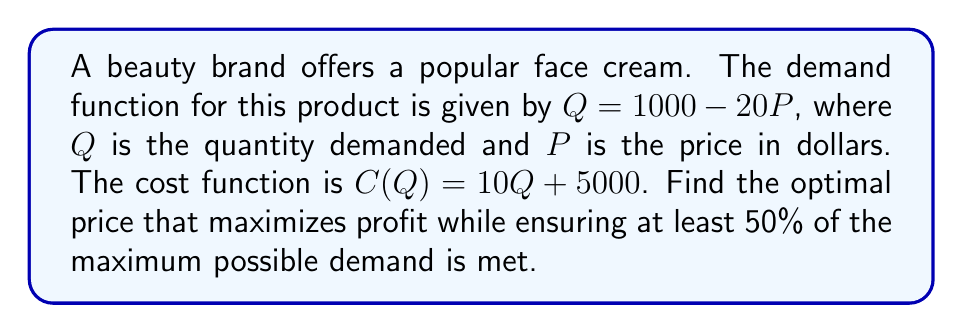What is the answer to this math problem? To solve this optimization problem, we'll follow these steps:

1) First, let's find the revenue function $R(P)$:
   $R(P) = P \cdot Q = P(1000 - 20P) = 1000P - 20P^2$

2) The cost function in terms of P:
   $C(P) = 10(1000 - 20P) + 5000 = 15000 - 200P$

3) The profit function $\pi(P)$ is revenue minus cost:
   $\pi(P) = R(P) - C(P) = (1000P - 20P^2) - (15000 - 200P)$
   $\pi(P) = 1200P - 20P^2 - 15000$

4) To find the maximum profit, we differentiate $\pi(P)$ and set it to zero:
   $\frac{d\pi}{dP} = 1200 - 40P = 0$
   $40P = 1200$
   $P = 30$

5) The second derivative $\frac{d^2\pi}{dP^2} = -40 < 0$, confirming this is a maximum.

6) Now, we need to check if this price meets our demand constraint:
   At $P = 30$, $Q = 1000 - 20(30) = 400$
   Maximum possible demand (at $P = 0$) is 1000.
   $\frac{400}{1000} = 0.4$ or 40%, which is less than our 50% requirement.

7) To meet the 50% demand requirement:
   $0.5 \cdot 1000 = 500 = 1000 - 20P$
   $20P = 500$
   $P = 25$

8) Therefore, the optimal price that maximizes profit while meeting the demand constraint is $25.
Answer: $25 